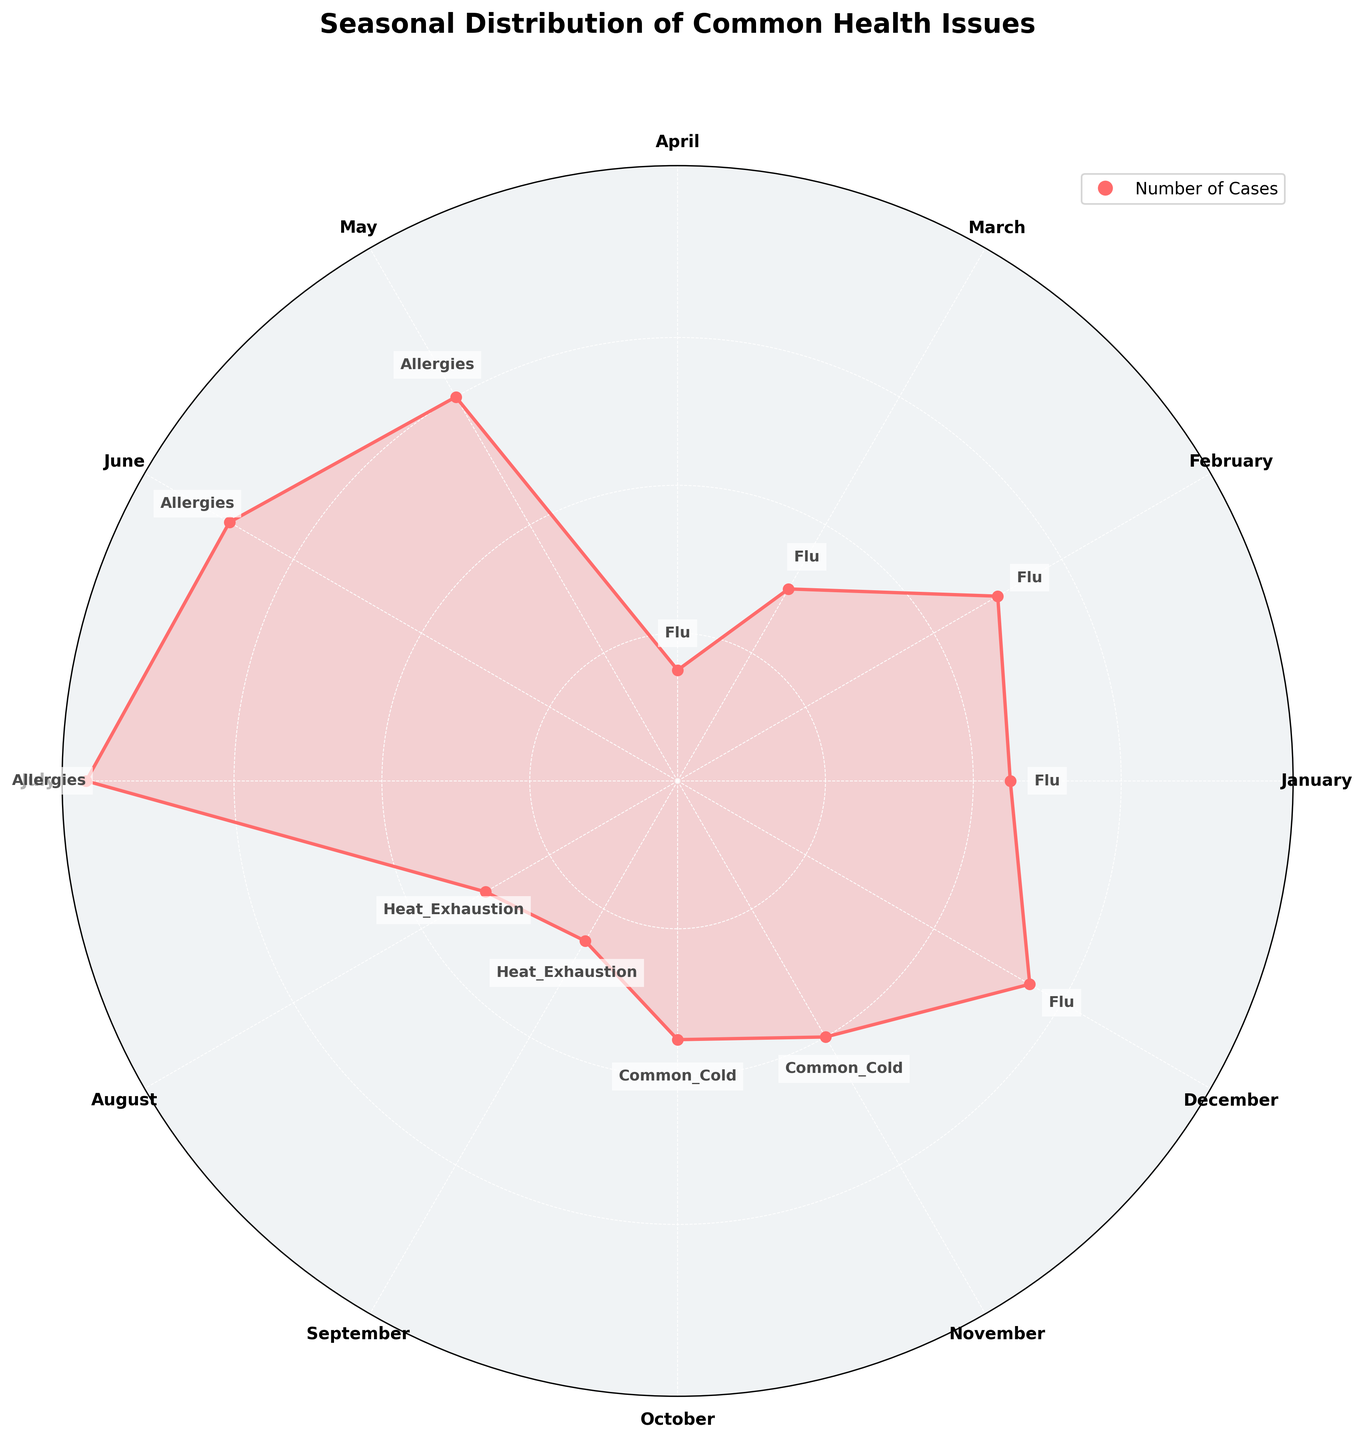How many months had cases of the flu? Referring to the chart, the flu is indicated in January, February, March, April, and December. Counting these months gives five months with flu cases.
Answer: 5 In which month were allergies most prevalent? Looking at the chart, allergies are present in May, June, and July. The highest number of cases for allergies is in July.
Answer: July Compare the number of flu cases in January and February. Which month had more cases? Observing the chart, January had 45 cases of the flu, while February had 50 cases. Therefore, February had more flu cases than January.
Answer: February What is the seasonal trend for heat exhaustion? The chart shows heat exhaustion cases in August and September. The number of cases is higher in August (30 cases) than in September (25 cases), indicating that heat exhaustion cases decrease as summer ends.
Answer: Decrease from August to September What is the total number of cases for common colds across all months? Common cold cases occur in October (35 cases) and November (40 cases). Adding these numbers together, 35 + 40 = 75.
Answer: 75 Which health issue had the highest number of cases in any single month? Referring to the chart, July had the highest number of cases (80), and the health issue during July was allergies.
Answer: Allergies How do flu cases in December compare to the average number of flu cases in April and March? December had 55 flu cases. April had 15 cases, and March had 30 cases. The average for April and March is (15 + 30) / 2 = 22.5. December's flu cases (55) are significantly higher than the average of April and March (22.5).
Answer: Higher What is the most common health issue during the winter season (December, January, February)? The chart shows that flu cases are predominant in December, January, and February.
Answer: Flu Is the number of allergy cases in June greater than the total number of cases for heat exhaustion? There are 70 allergy cases in June, while heat exhaustion cases are 30 in August and 25 in September. The total for heat exhaustion is 30 + 25 = 55. Comparing these, June's allergy cases are more than the total heat exhaustion cases.
Answer: Yes Which month marked the peak for flu cases, and what was the number of cases? By observing the chart, the peak for flu cases is in February with 50 cases.
Answer: February, 50 